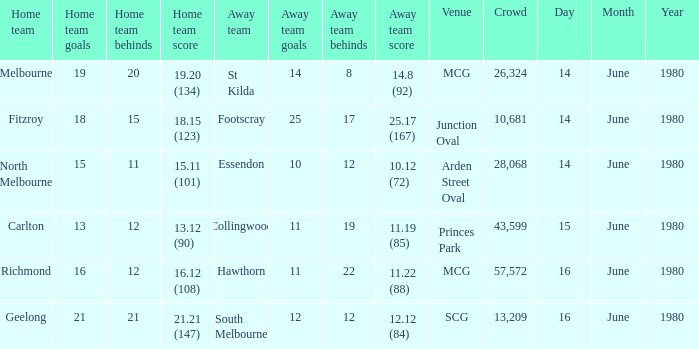On what date the footscray's away game? 14 June 1980. 